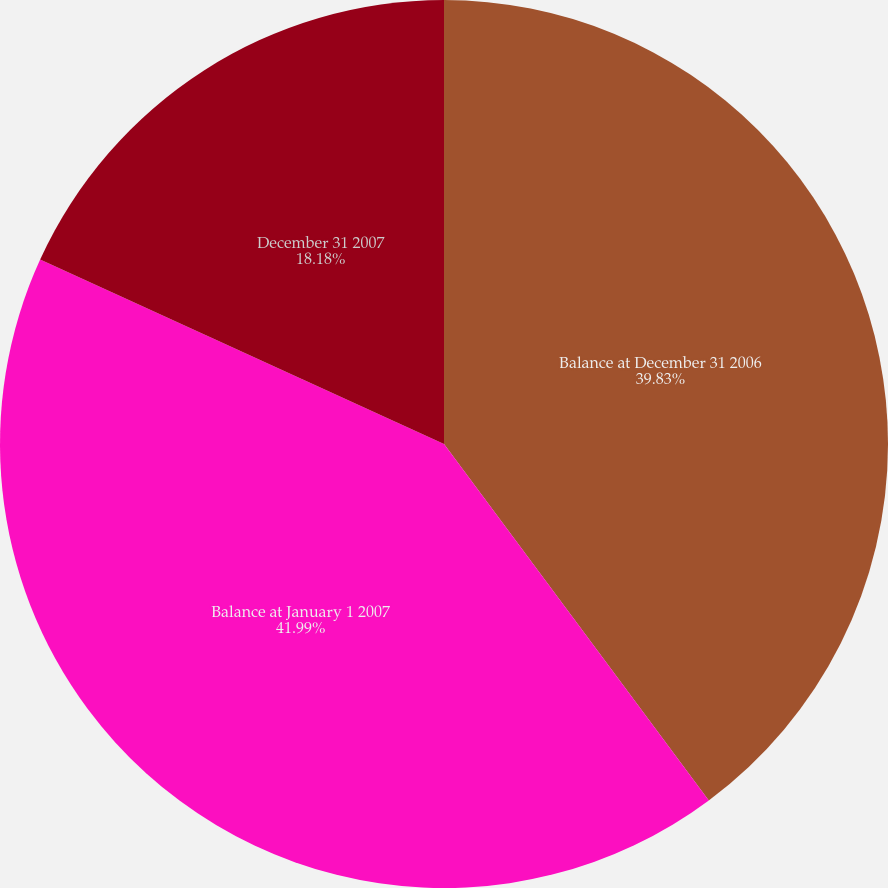Convert chart. <chart><loc_0><loc_0><loc_500><loc_500><pie_chart><fcel>Balance at December 31 2006<fcel>Balance at January 1 2007<fcel>December 31 2007<nl><fcel>39.83%<fcel>41.99%<fcel>18.18%<nl></chart> 